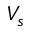Convert formula to latex. <formula><loc_0><loc_0><loc_500><loc_500>V _ { s }</formula> 